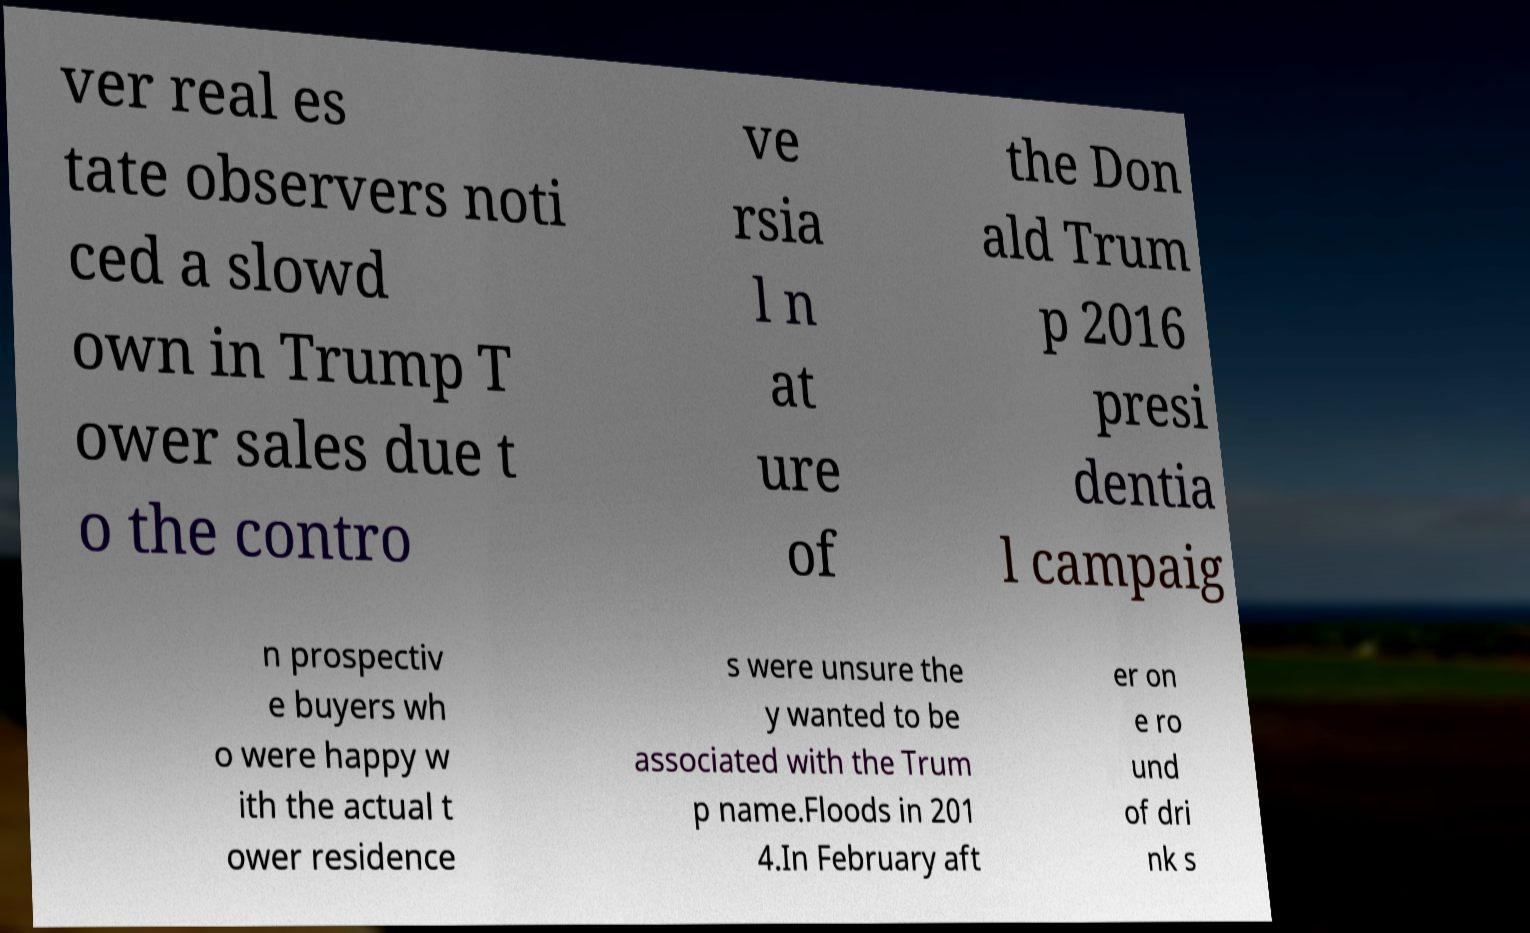Can you read and provide the text displayed in the image?This photo seems to have some interesting text. Can you extract and type it out for me? ver real es tate observers noti ced a slowd own in Trump T ower sales due t o the contro ve rsia l n at ure of the Don ald Trum p 2016 presi dentia l campaig n prospectiv e buyers wh o were happy w ith the actual t ower residence s were unsure the y wanted to be associated with the Trum p name.Floods in 201 4.In February aft er on e ro und of dri nk s 